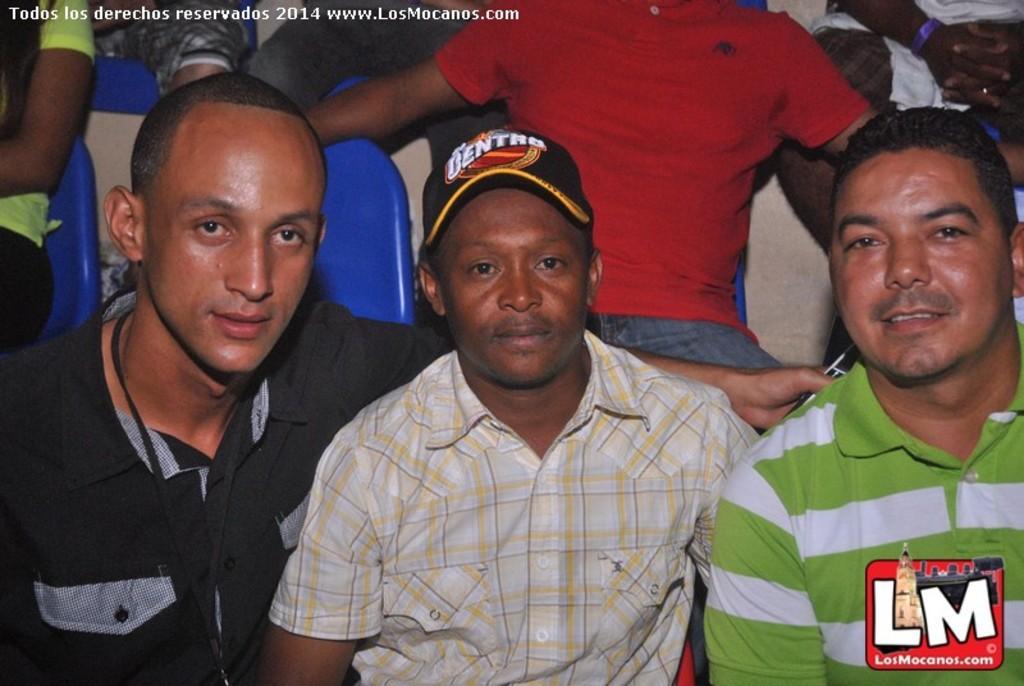In one or two sentences, can you explain what this image depicts? In this picture, there are three men sitting on the chairs. Towards the left, there is a man wearing black shirt. In the center, there is another man wearing check shirt and a cap. Towards the right, there is a man in striped shirt. At the top, there is another man wearing red t shirt. In the background, there are people. 